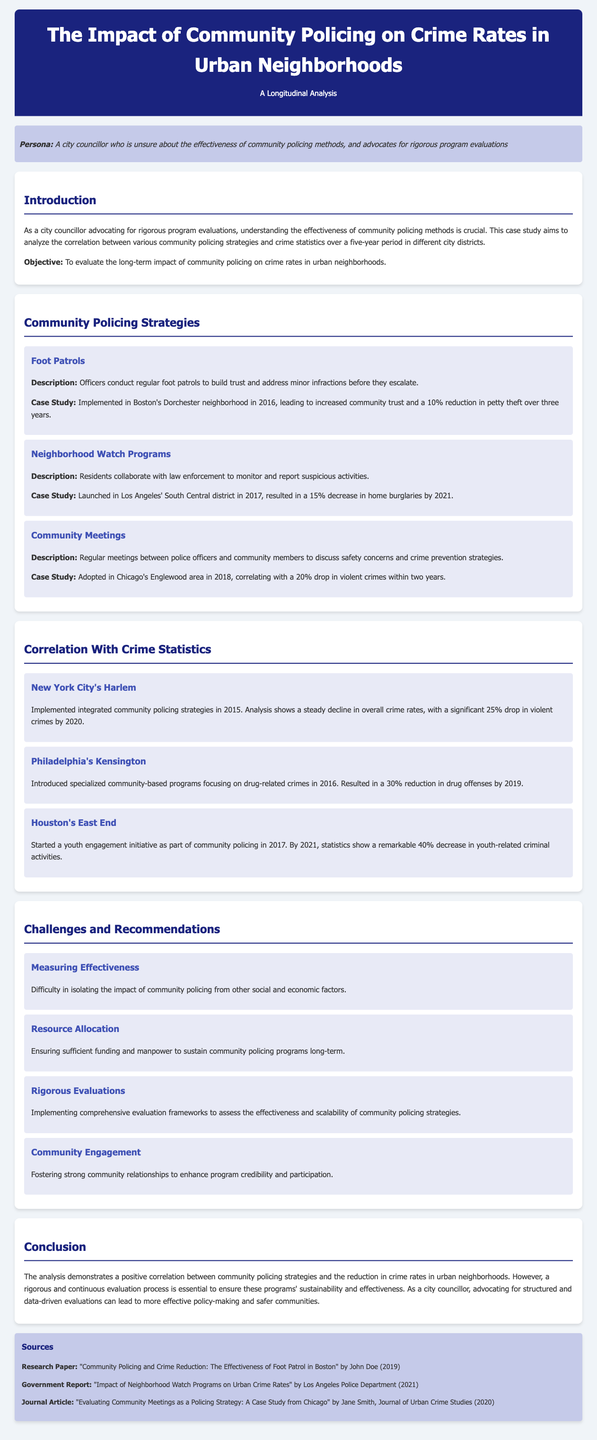What is the objective of the case study? The objective of the case study is to evaluate the long-term impact of community policing on crime rates in urban neighborhoods.
Answer: To evaluate the long-term impact of community policing on crime rates in urban neighborhoods What reduction in petty theft was achieved in Dorchester? The case study mentions a 10% reduction in petty theft.
Answer: 10% In what year were neighborhood watch programs launched in South Central Los Angeles? The document states that neighborhood watch programs were launched in 2017.
Answer: 2017 What percentage drop in violent crimes was reported in Chicago's Englewood area? The case study reports a 20% drop in violent crimes within two years.
Answer: 20% What was a significant challenge mentioned regarding community policing? The document highlights the difficulty in isolating the impact of community policing from other social and economic factors as a significant challenge.
Answer: Difficulty in isolating the impact What is one recommended approach for ensuring the effectiveness of community policing? The case study recommends implementing comprehensive evaluation frameworks to assess effectiveness.
Answer: Rigorous Evaluations How much did drug offenses reduce in Philadelphia's Kensington by 2019? The analysis shows a 30% reduction in drug offenses by 2019.
Answer: 30% Which community policing strategy led to a 40% decrease in youth-related criminal activities? The initiative in Houston's East End, focusing on youth engagement, led to this decrease.
Answer: Youth engagement initiative What year did community policing strategies integrate in New York City's Harlem? The document states that integrated community policing strategies were implemented in 2015.
Answer: 2015 